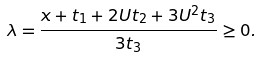<formula> <loc_0><loc_0><loc_500><loc_500>\lambda = \frac { x + t _ { 1 } + 2 U t _ { 2 } + 3 U ^ { 2 } t _ { 3 } } { 3 t _ { 3 } } \geq 0 .</formula> 